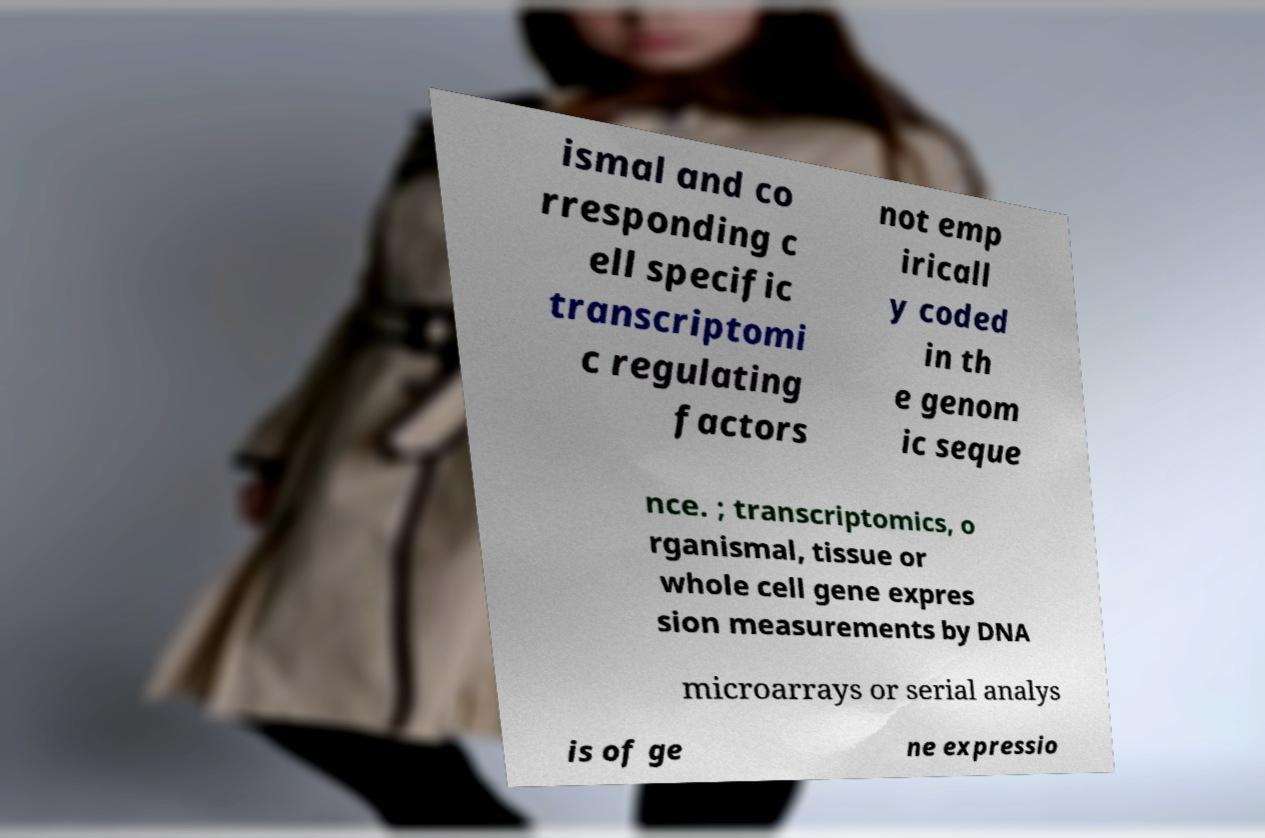Please read and relay the text visible in this image. What does it say? ismal and co rresponding c ell specific transcriptomi c regulating factors not emp iricall y coded in th e genom ic seque nce. ; transcriptomics, o rganismal, tissue or whole cell gene expres sion measurements by DNA microarrays or serial analys is of ge ne expressio 